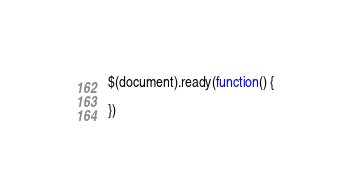<code> <loc_0><loc_0><loc_500><loc_500><_JavaScript_>
$(document).ready(function() {

})</code> 